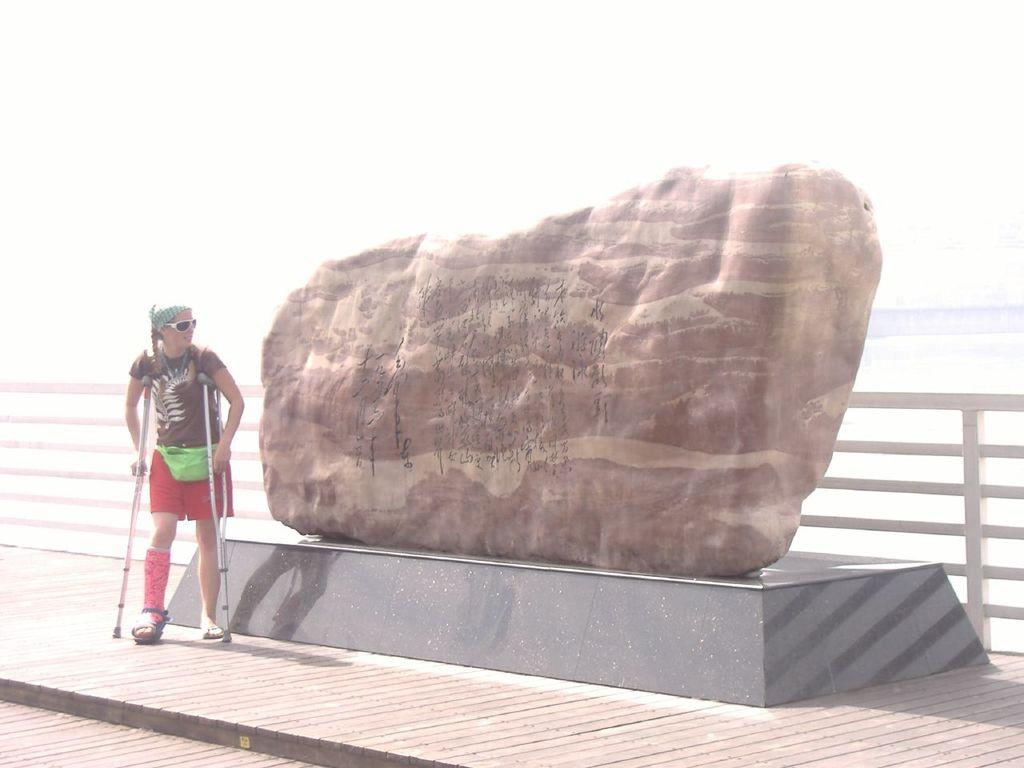Who is the main subject in the image? There is a girl in the image. What is the girl doing in the image? The girl is standing near a rock. Where is the rock located in the image? The rock is on the left side of the image. Reasoning: Let'ing: Let's think step by step in order to produce the conversation. We start by identifying the main subject in the image, which is the girl. Then, we describe her action, which is standing near a rock. Finally, we specify the location of the rock in the image, which is on the left side. Each question is designed to elicit a specific detail about the image that is known from the provided facts. Absurd Question/Answer: What type of insect can be seen flying near the girl in the image? There is no insect present in the image; it only features a girl standing near a rock. What type of pies is the girl holding in the image? There is no mention of pies in the image; it only features a girl standing near a rock. 